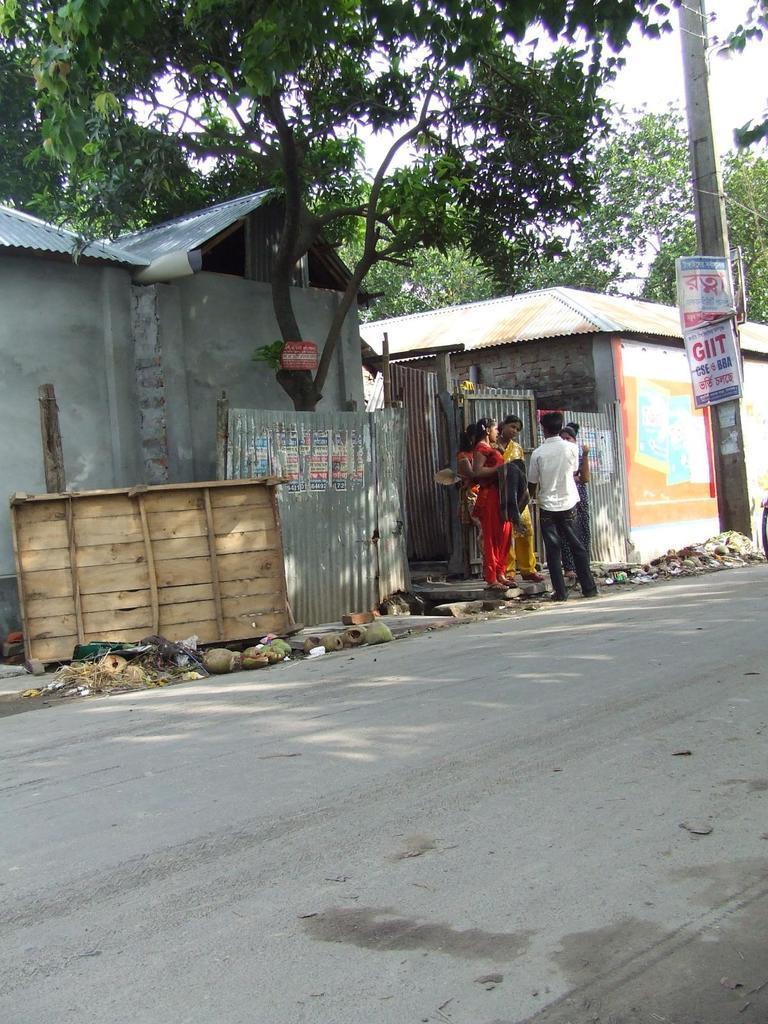Can you describe this image briefly? In the foreground of this image, there is the road. In the background, there is a pole, banners, persons standing, a wooden object, metal sheets, two houses, trees and the sky. 